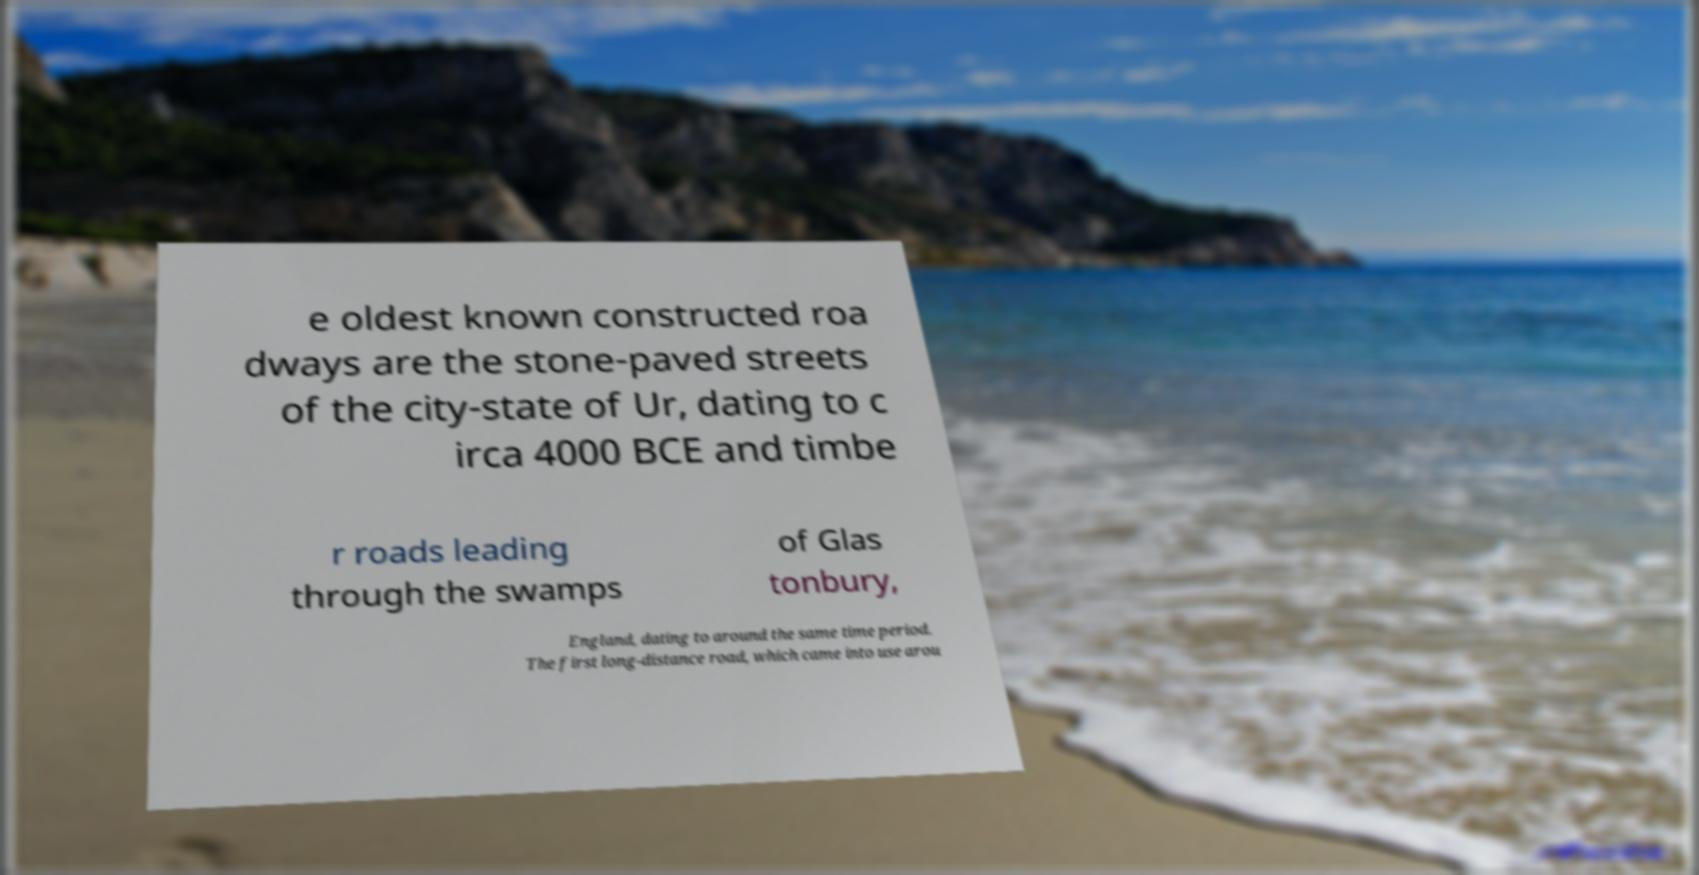Could you assist in decoding the text presented in this image and type it out clearly? e oldest known constructed roa dways are the stone-paved streets of the city-state of Ur, dating to c irca 4000 BCE and timbe r roads leading through the swamps of Glas tonbury, England, dating to around the same time period. The first long-distance road, which came into use arou 